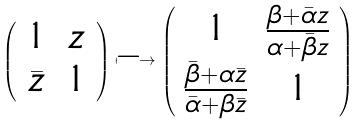Convert formula to latex. <formula><loc_0><loc_0><loc_500><loc_500>\left ( \begin{array} { c c } 1 & z \\ \bar { z } & 1 \end{array} \right ) \longmapsto \left ( \begin{array} { c c } 1 & \frac { \beta + \bar { \alpha } z } { \alpha + \bar { \beta } z } \\ \frac { \bar { \beta } + \alpha \bar { z } } { \bar { \alpha } + \beta \bar { z } } & 1 \end{array} \right )</formula> 